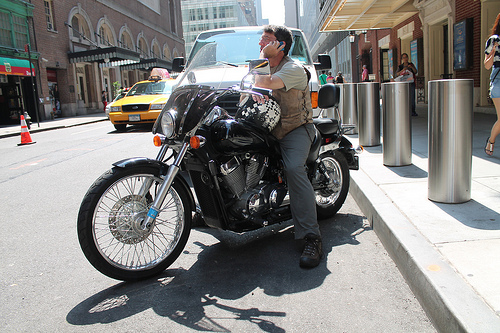On which side is the taxi? The taxi is parked on the left side of the image, near the sidewalk where people are walking. 